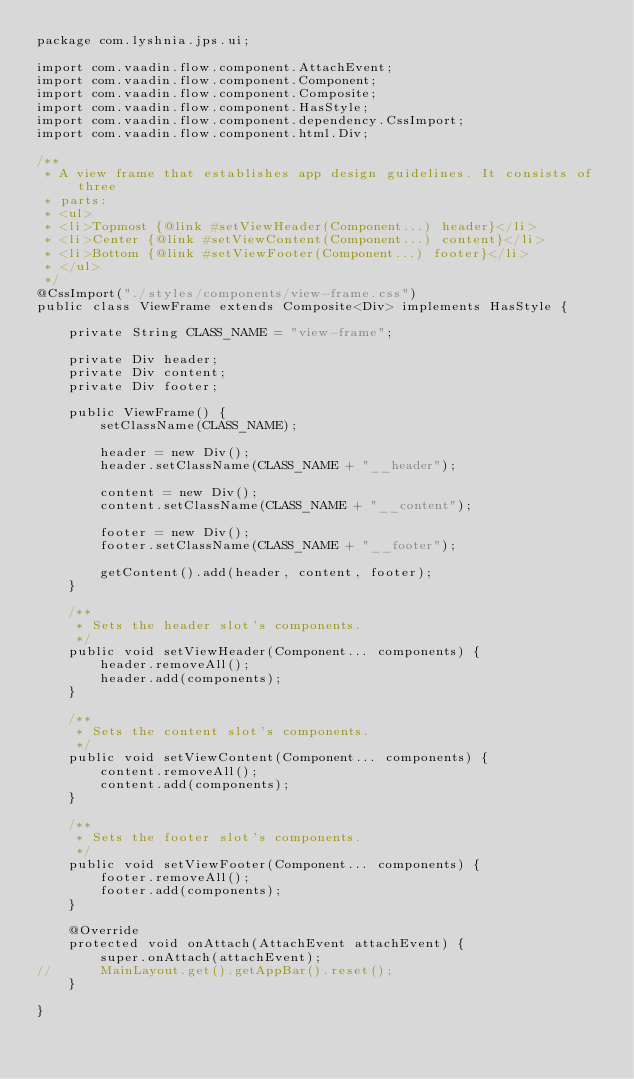<code> <loc_0><loc_0><loc_500><loc_500><_Java_>package com.lyshnia.jps.ui;

import com.vaadin.flow.component.AttachEvent;
import com.vaadin.flow.component.Component;
import com.vaadin.flow.component.Composite;
import com.vaadin.flow.component.HasStyle;
import com.vaadin.flow.component.dependency.CssImport;
import com.vaadin.flow.component.html.Div;

/**
 * A view frame that establishes app design guidelines. It consists of three
 * parts:
 * <ul>
 * <li>Topmost {@link #setViewHeader(Component...) header}</li>
 * <li>Center {@link #setViewContent(Component...) content}</li>
 * <li>Bottom {@link #setViewFooter(Component...) footer}</li>
 * </ul>
 */
@CssImport("./styles/components/view-frame.css")
public class ViewFrame extends Composite<Div> implements HasStyle {

    private String CLASS_NAME = "view-frame";

    private Div header;
    private Div content;
    private Div footer;

    public ViewFrame() {
        setClassName(CLASS_NAME);

        header = new Div();
        header.setClassName(CLASS_NAME + "__header");

        content = new Div();
        content.setClassName(CLASS_NAME + "__content");

        footer = new Div();
        footer.setClassName(CLASS_NAME + "__footer");

        getContent().add(header, content, footer);
    }

    /**
     * Sets the header slot's components.
     */
    public void setViewHeader(Component... components) {
        header.removeAll();
        header.add(components);
    }

    /**
     * Sets the content slot's components.
     */
    public void setViewContent(Component... components) {
        content.removeAll();
        content.add(components);
    }

    /**
     * Sets the footer slot's components.
     */
    public void setViewFooter(Component... components) {
        footer.removeAll();
        footer.add(components);
    }

    @Override
    protected void onAttach(AttachEvent attachEvent) {
        super.onAttach(attachEvent);
//		MainLayout.get().getAppBar().reset();
    }

}
</code> 